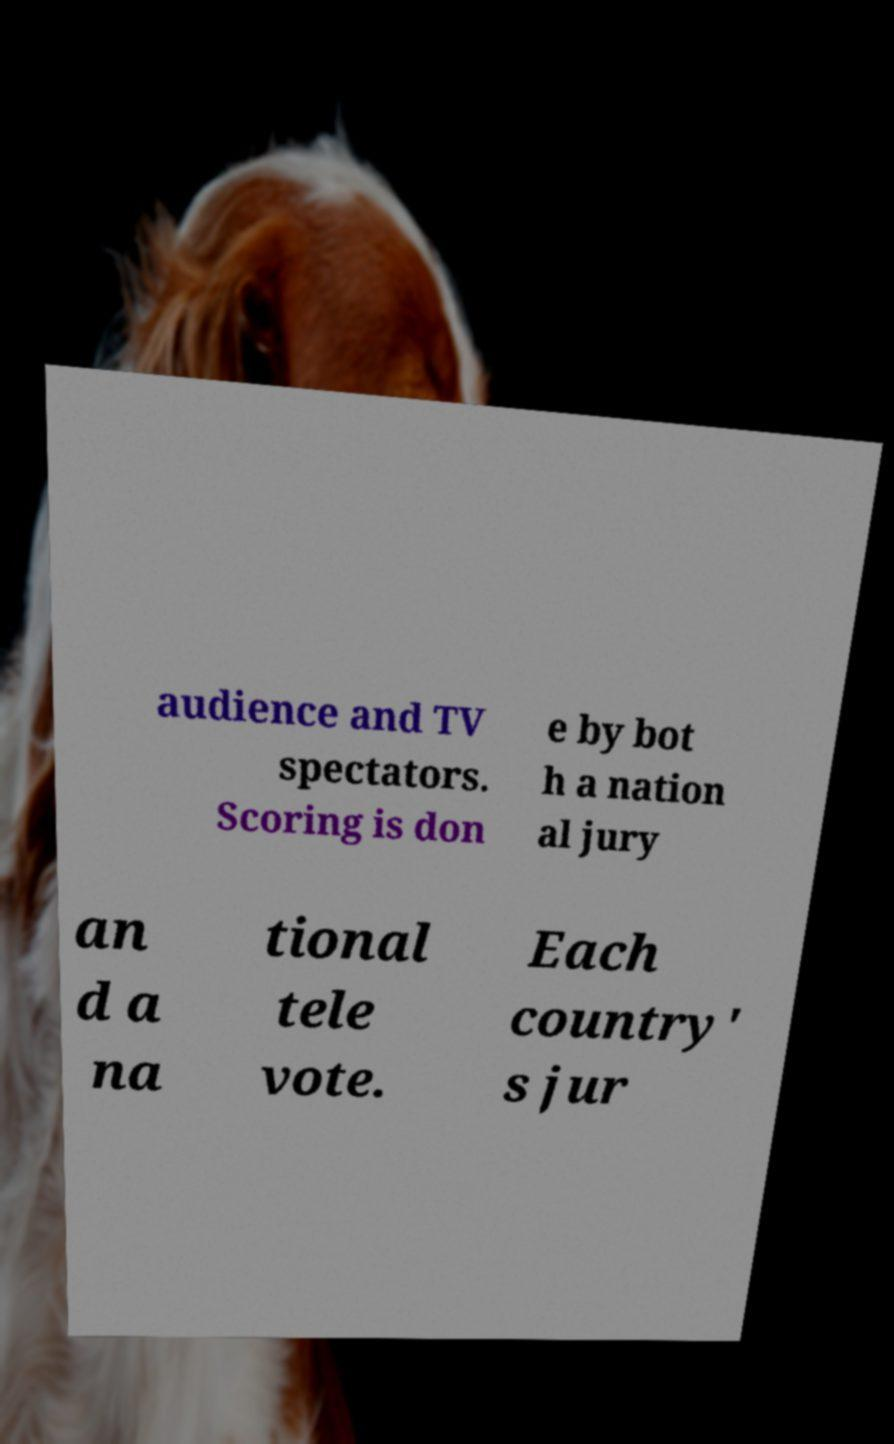There's text embedded in this image that I need extracted. Can you transcribe it verbatim? audience and TV spectators. Scoring is don e by bot h a nation al jury an d a na tional tele vote. Each country' s jur 